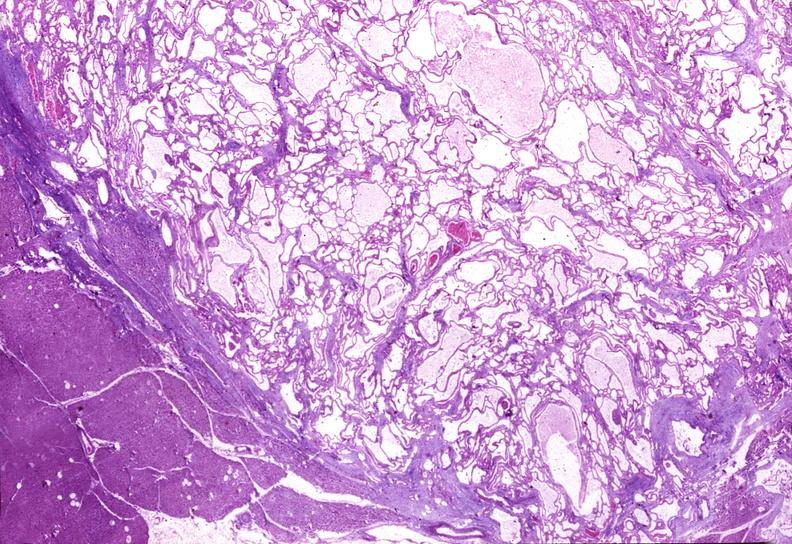what is present?
Answer the question using a single word or phrase. Pancreas 